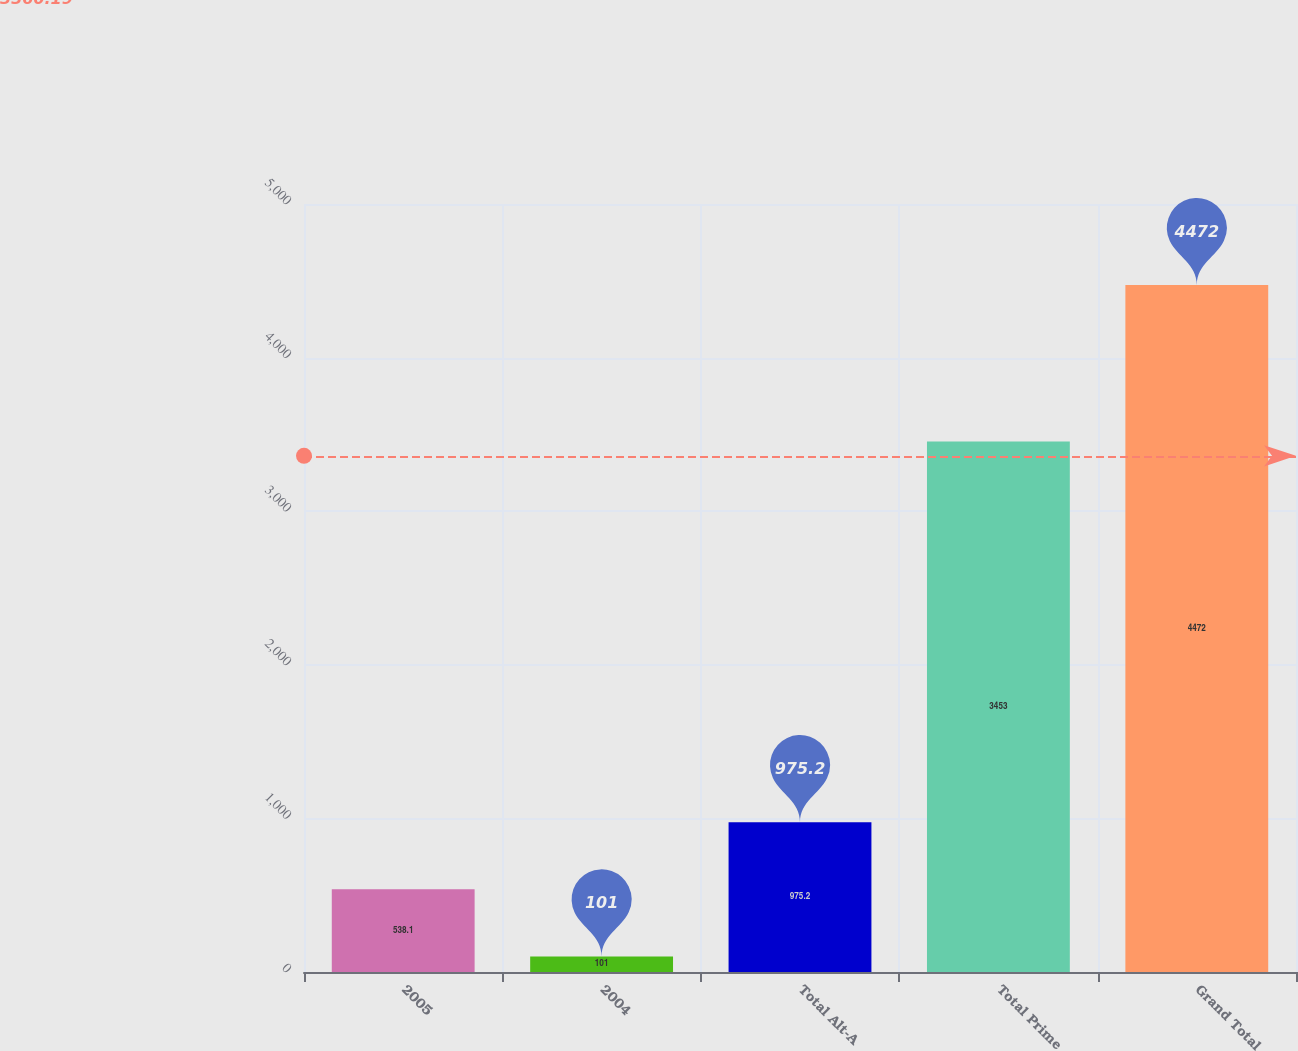Convert chart. <chart><loc_0><loc_0><loc_500><loc_500><bar_chart><fcel>2005<fcel>2004<fcel>Total Alt-A<fcel>Total Prime<fcel>Grand Total<nl><fcel>538.1<fcel>101<fcel>975.2<fcel>3453<fcel>4472<nl></chart> 